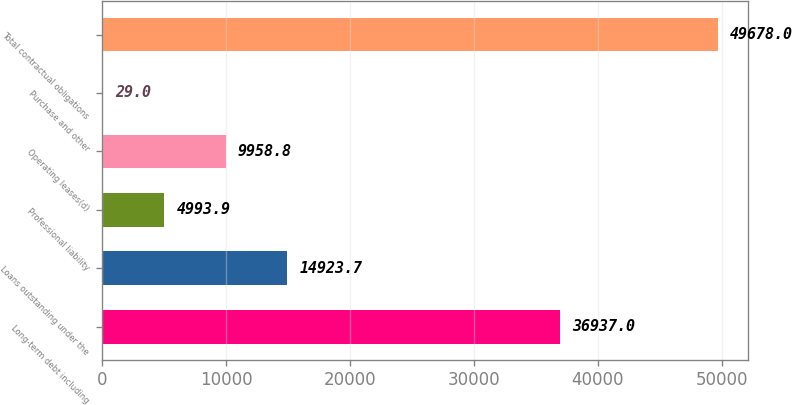Convert chart. <chart><loc_0><loc_0><loc_500><loc_500><bar_chart><fcel>Long-term debt including<fcel>Loans outstanding under the<fcel>Professional liability<fcel>Operating leases(d)<fcel>Purchase and other<fcel>Total contractual obligations<nl><fcel>36937<fcel>14923.7<fcel>4993.9<fcel>9958.8<fcel>29<fcel>49678<nl></chart> 